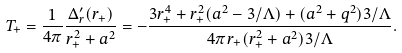Convert formula to latex. <formula><loc_0><loc_0><loc_500><loc_500>T _ { + } = \frac { 1 } { 4 \pi } \frac { \Delta _ { r } ^ { \prime } ( r _ { + } ) } { r _ { + } ^ { 2 } + a ^ { 2 } } = - \frac { 3 r _ { + } ^ { 4 } + r _ { + } ^ { 2 } ( a ^ { 2 } - 3 / \Lambda ) + ( a ^ { 2 } + q ^ { 2 } ) 3 / \Lambda } { 4 \pi r _ { + } ( r _ { + } ^ { 2 } + a ^ { 2 } ) 3 / \Lambda } .</formula> 